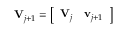Convert formula to latex. <formula><loc_0><loc_0><loc_500><loc_500>V _ { j + 1 } = \left [ \begin{array} { l l } { V _ { j } } & { v _ { j + 1 } } \end{array} \right ]</formula> 